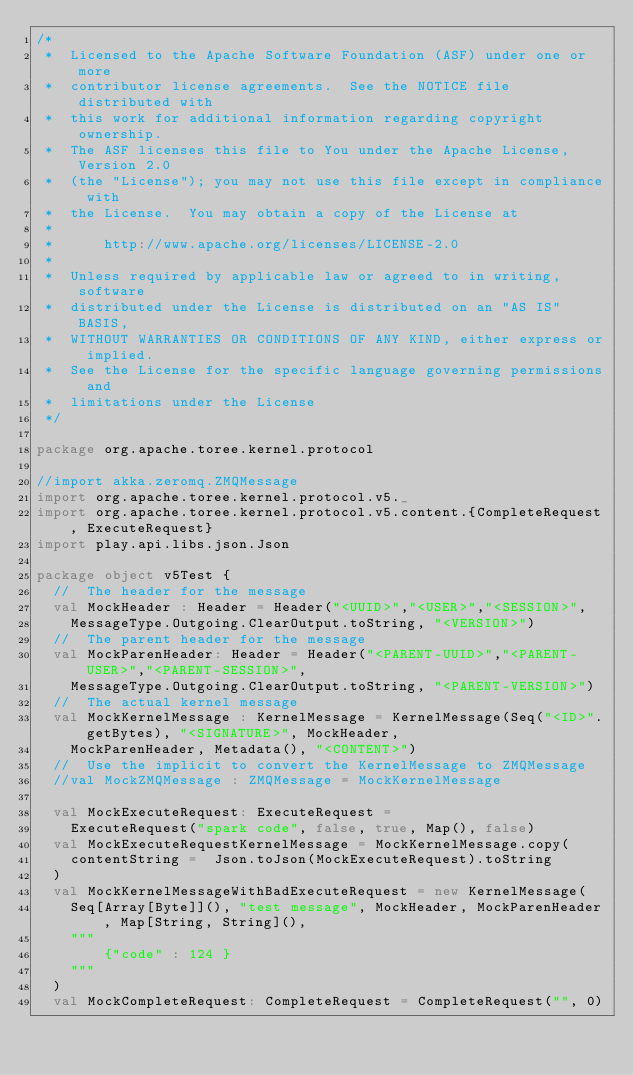<code> <loc_0><loc_0><loc_500><loc_500><_Scala_>/*
 *  Licensed to the Apache Software Foundation (ASF) under one or more
 *  contributor license agreements.  See the NOTICE file distributed with
 *  this work for additional information regarding copyright ownership.
 *  The ASF licenses this file to You under the Apache License, Version 2.0
 *  (the "License"); you may not use this file except in compliance with
 *  the License.  You may obtain a copy of the License at
 *
 *      http://www.apache.org/licenses/LICENSE-2.0
 *
 *  Unless required by applicable law or agreed to in writing, software
 *  distributed under the License is distributed on an "AS IS" BASIS,
 *  WITHOUT WARRANTIES OR CONDITIONS OF ANY KIND, either express or implied.
 *  See the License for the specific language governing permissions and
 *  limitations under the License
 */

package org.apache.toree.kernel.protocol

//import akka.zeromq.ZMQMessage
import org.apache.toree.kernel.protocol.v5._
import org.apache.toree.kernel.protocol.v5.content.{CompleteRequest, ExecuteRequest}
import play.api.libs.json.Json

package object v5Test {
  //  The header for the message
  val MockHeader : Header = Header("<UUID>","<USER>","<SESSION>",
    MessageType.Outgoing.ClearOutput.toString, "<VERSION>")
  //  The parent header for the message
  val MockParenHeader: Header = Header("<PARENT-UUID>","<PARENT-USER>","<PARENT-SESSION>",
    MessageType.Outgoing.ClearOutput.toString, "<PARENT-VERSION>")
  //  The actual kernel message
  val MockKernelMessage : KernelMessage = KernelMessage(Seq("<ID>".getBytes), "<SIGNATURE>", MockHeader,
    MockParenHeader, Metadata(), "<CONTENT>")
  //  Use the implicit to convert the KernelMessage to ZMQMessage
  //val MockZMQMessage : ZMQMessage = MockKernelMessage

  val MockExecuteRequest: ExecuteRequest =
    ExecuteRequest("spark code", false, true, Map(), false)
  val MockExecuteRequestKernelMessage = MockKernelMessage.copy(
    contentString =  Json.toJson(MockExecuteRequest).toString
  )
  val MockKernelMessageWithBadExecuteRequest = new KernelMessage(
    Seq[Array[Byte]](), "test message", MockHeader, MockParenHeader, Map[String, String](),
    """
        {"code" : 124 }
    """
  )
  val MockCompleteRequest: CompleteRequest = CompleteRequest("", 0)</code> 